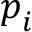<formula> <loc_0><loc_0><loc_500><loc_500>p _ { i }</formula> 